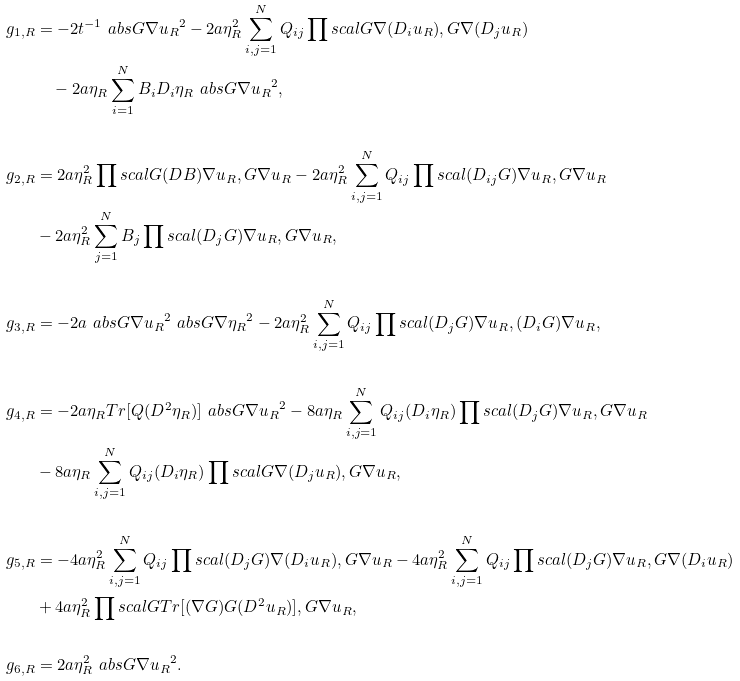<formula> <loc_0><loc_0><loc_500><loc_500>g _ { 1 , R } & = - 2 t ^ { - 1 } \ a b s { G \nabla u _ { R } } ^ { 2 } - 2 a \eta _ { R } ^ { 2 } \sum _ { i , j = 1 } ^ { N } Q _ { i j } \prod s c a l { G \nabla ( D _ { i } u _ { R } ) , G \nabla ( D _ { j } u _ { R } ) } \\ & \quad - 2 a \eta _ { R } \sum _ { i = 1 } ^ { N } B _ { i } D _ { i } \eta _ { R } \ a b s { G \nabla u _ { R } } ^ { 2 } , \\ \\ g _ { 2 , R } & = 2 a \eta _ { R } ^ { 2 } \prod s c a l { G ( D B ) \nabla u _ { R } , G \nabla u _ { R } } - 2 a \eta _ { R } ^ { 2 } \sum _ { i , j = 1 } ^ { N } Q _ { i j } \prod s c a l { ( D _ { i j } G ) \nabla u _ { R } , G \nabla u _ { R } } \\ \quad & - 2 a \eta _ { R } ^ { 2 } \sum _ { j = 1 } ^ { N } B _ { j } \prod s c a l { ( D _ { j } G ) \nabla u _ { R } , G \nabla u _ { R } } , \\ \\ g _ { 3 , R } & = - 2 a \ a b s { G \nabla u _ { R } } ^ { 2 } \ a b s { G \nabla \eta _ { R } } ^ { 2 } - 2 a \eta _ { R } ^ { 2 } \sum _ { i , j = 1 } ^ { N } Q _ { i j } \prod s c a l { ( D _ { j } G ) \nabla u _ { R } , ( D _ { i } G ) \nabla u _ { R } } , \\ \\ g _ { 4 , R } & = - 2 a \eta _ { R } T r [ Q ( D ^ { 2 } \eta _ { R } ) ] \ a b s { G \nabla u _ { R } } ^ { 2 } - 8 a \eta _ { R } \sum _ { i , j = 1 } ^ { N } Q _ { i j } ( D _ { i } \eta _ { R } ) \prod s c a l { ( D _ { j } G ) \nabla u _ { R } , G \nabla u _ { R } } \\ \quad & - 8 a \eta _ { R } \sum _ { i , j = 1 } ^ { N } Q _ { i j } ( D _ { i } \eta _ { R } ) \prod s c a l { G \nabla ( D _ { j } u _ { R } ) , G \nabla u _ { R } } , \\ \\ g _ { 5 , R } & = - 4 a \eta _ { R } ^ { 2 } \sum _ { i , j = 1 } ^ { N } Q _ { i j } \prod s c a l { ( D _ { j } G ) \nabla ( D _ { i } u _ { R } ) , G \nabla u _ { R } } - 4 a \eta _ { R } ^ { 2 } \sum _ { i , j = 1 } ^ { N } Q _ { i j } \prod s c a l { ( D _ { j } G ) \nabla u _ { R } , G \nabla ( D _ { i } u _ { R } ) } \\ \quad & + 4 a \eta _ { R } ^ { 2 } \prod s c a l { G T r [ ( \nabla G ) G ( D ^ { 2 } u _ { R } ) ] , G \nabla u _ { R } } , \\ \\ g _ { 6 , R } & = 2 a \eta _ { R } ^ { 2 } \ a b s { G \nabla u _ { R } } ^ { 2 } .</formula> 